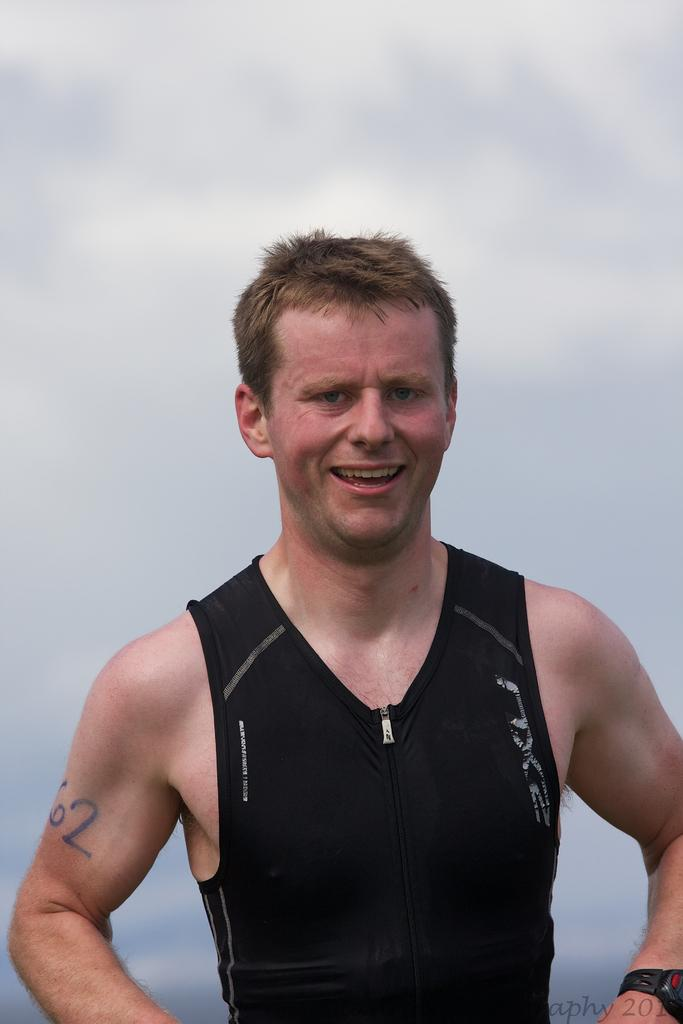What is present in the image? There is a person in the image. How is the person's expression in the image? The person is smiling. What can be seen in the background of the image? The sky is visible in the background of the image. What type of rock can be seen in the person's hand in the image? There is no rock present in the image, and the person's hands are not visible. How many bricks are visible in the image? There are no bricks present in the image. Are there any dinosaurs visible in the image? There are no dinosaurs present in the image. 